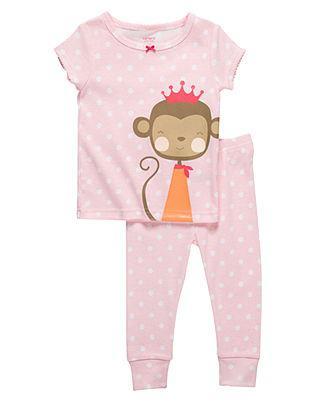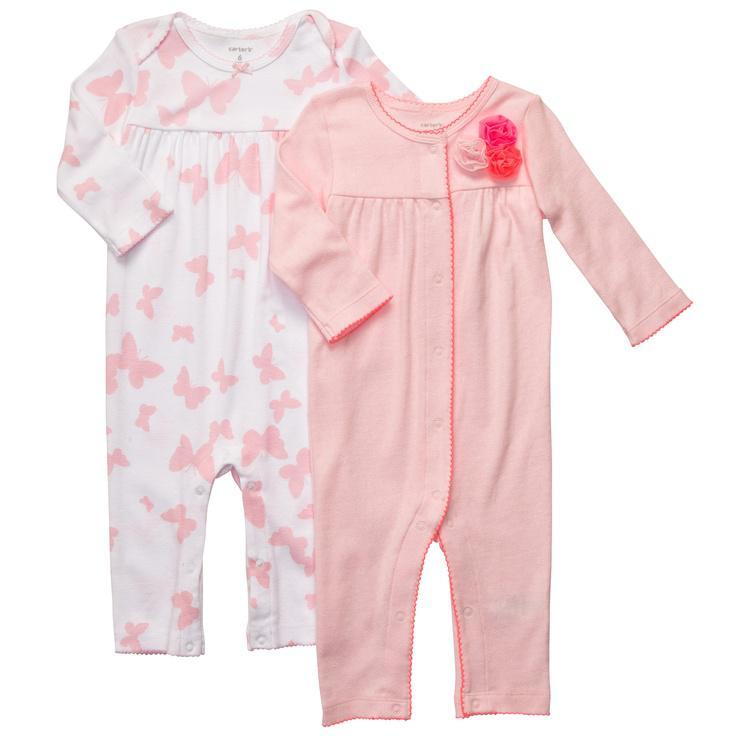The first image is the image on the left, the second image is the image on the right. Assess this claim about the two images: "There are two outfits in one of the images.". Correct or not? Answer yes or no. Yes. The first image is the image on the left, the second image is the image on the right. Examine the images to the left and right. Is the description "Sleepwear on the right features a Disney Princess theme on the front." accurate? Answer yes or no. No. 